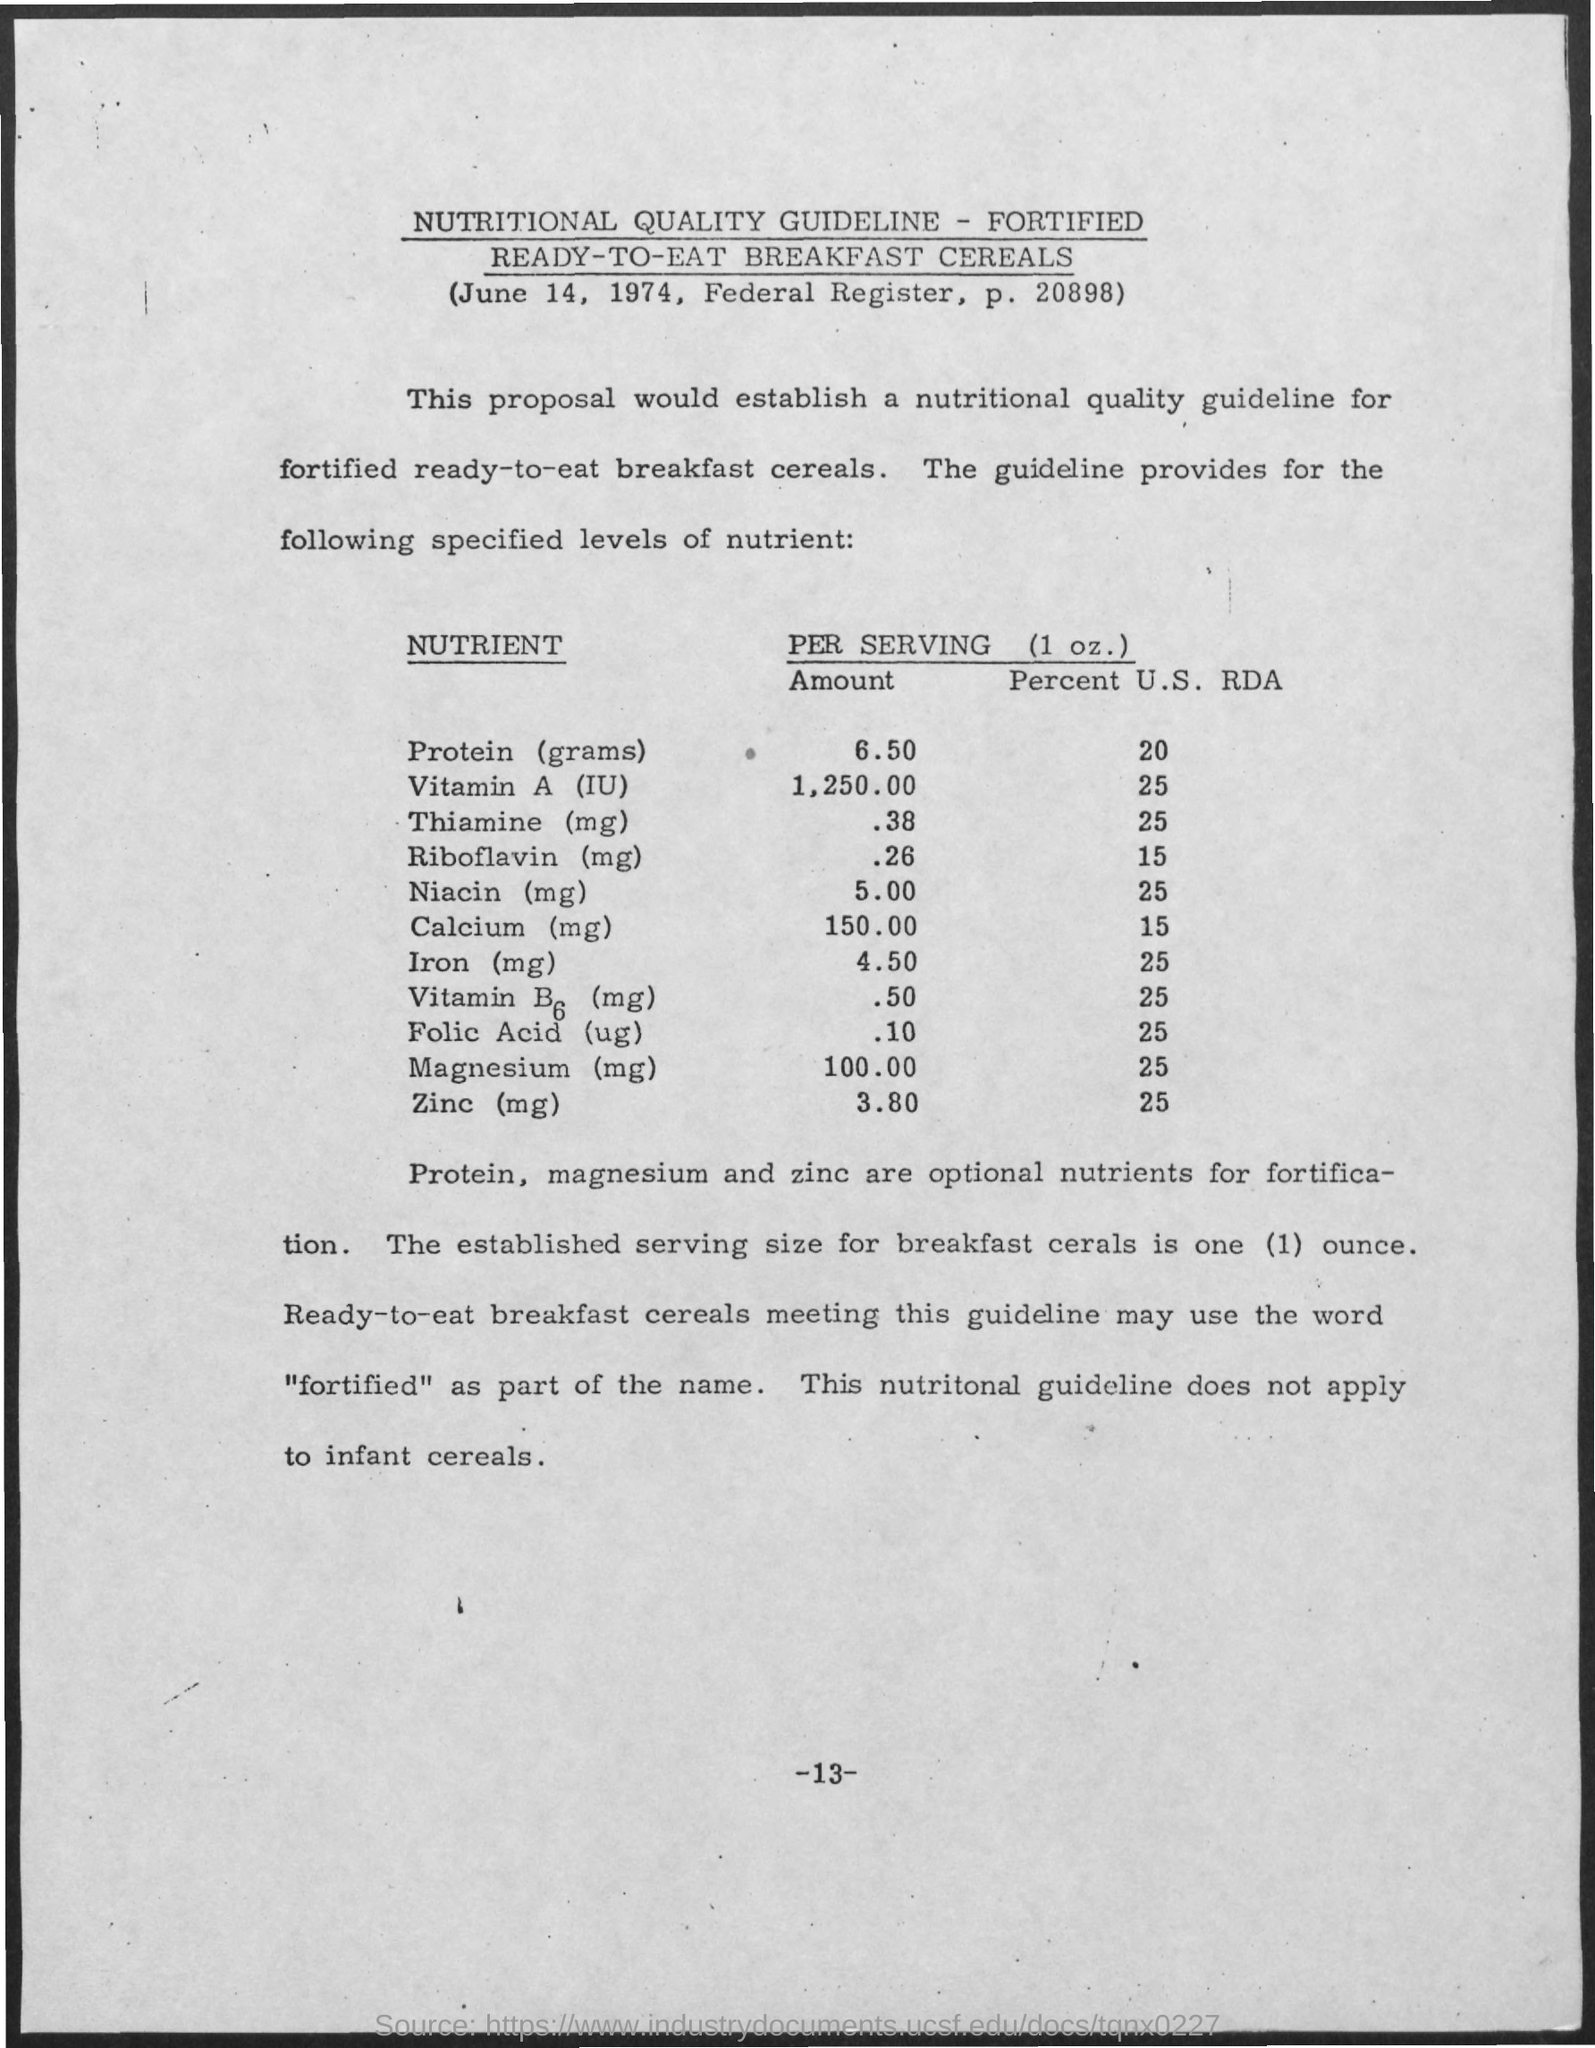Mention a couple of crucial points in this snapshot. Protein, magnesium, and zinc are optional nutrients that can be fortified in food products to enhance their nutritional value. 